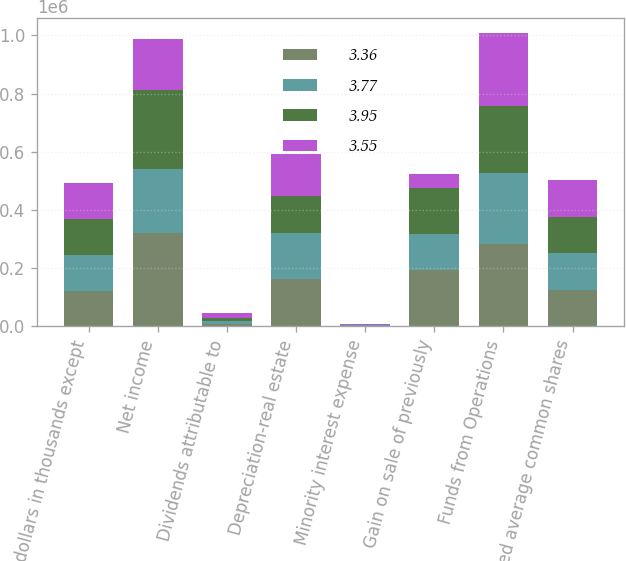Convert chart to OTSL. <chart><loc_0><loc_0><loc_500><loc_500><stacked_bar_chart><ecel><fcel>(dollars in thousands except<fcel>Net income<fcel>Dividends attributable to<fcel>Depreciation-real estate<fcel>Minority interest expense<fcel>Gain on sale of previously<fcel>Funds from Operations<fcel>Weighted average common shares<nl><fcel>3.36<fcel>123105<fcel>322378<fcel>8700<fcel>162019<fcel>1363<fcel>195287<fcel>281773<fcel>125692<nl><fcel>3.77<fcel>123104<fcel>219745<fcel>8700<fcel>157988<fcel>3048<fcel>121287<fcel>246247<fcel>125692<nl><fcel>3.95<fcel>123103<fcel>271525<fcel>10744<fcel>128278<fcel>1263<fcel>159756<fcel>230566<fcel>125692<nl><fcel>3.55<fcel>123102<fcel>173618<fcel>17896<fcel>142980<fcel>1601<fcel>48893<fcel>251410<fcel>125692<nl></chart> 